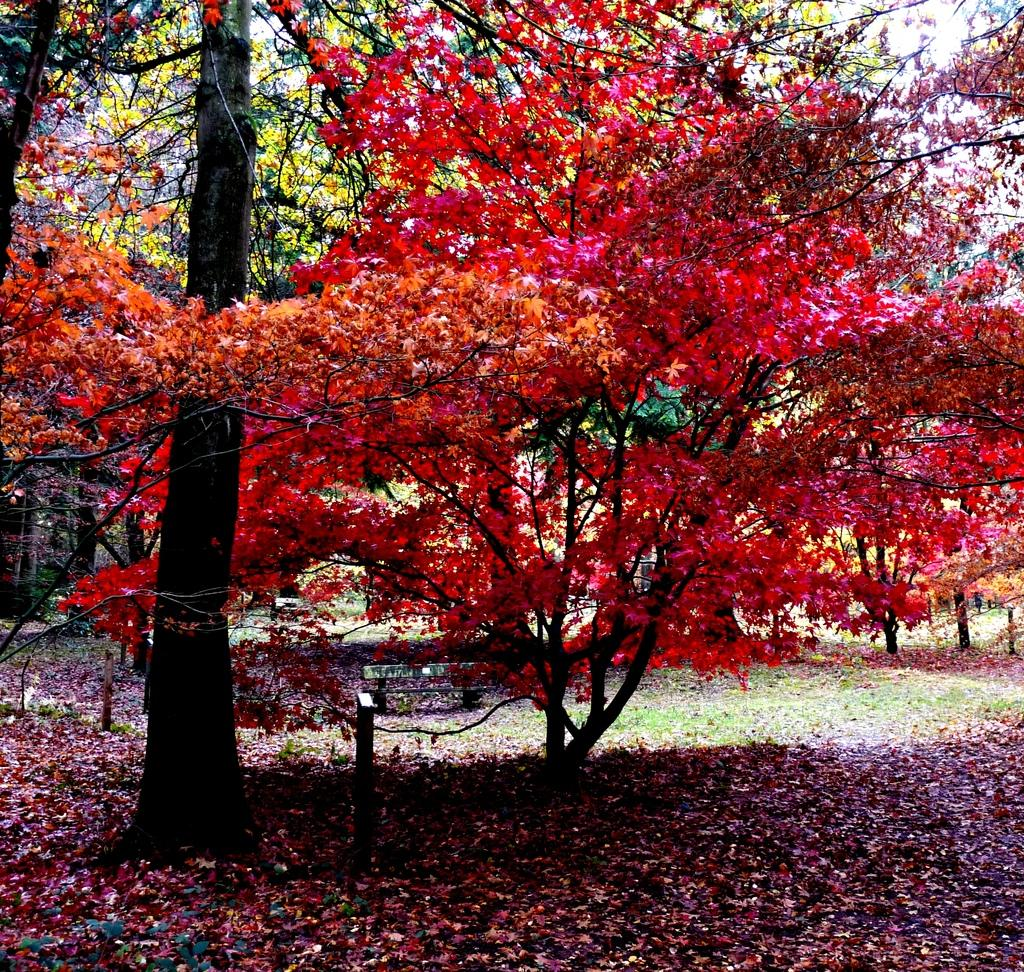What type of vegetation is visible in the image? There are many trees in the image. What type of seating is present in the image? There is a bench in the image. What can be seen on the ground in the image? Dried leaves are present on the ground in the image. What type of ground cover is visible in the image? Grasses are visible in the image. Can you tell me how many geese are depicted in the image? There are no geese depicted in the image; it features trees, a bench, dried leaves, and grasses. What type of property is shown in the image? The image does not depict any specific property; it shows a natural setting with trees, a bench, dried leaves, and grasses. 